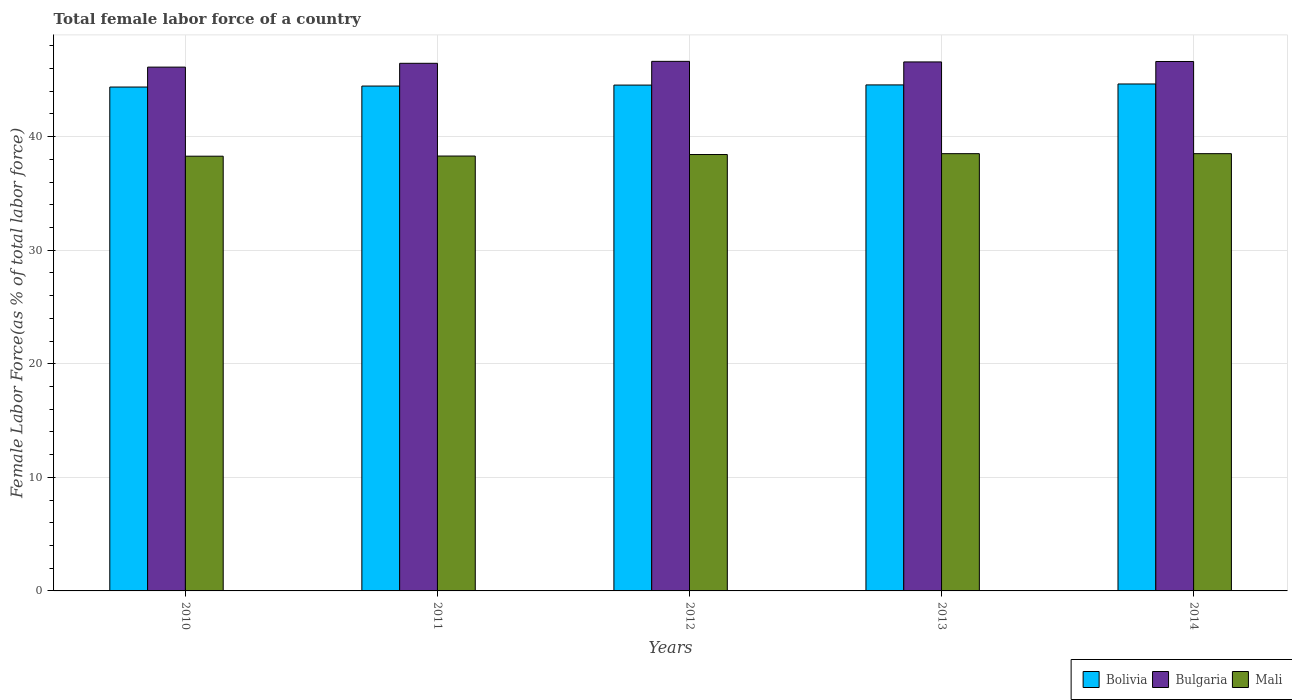How many different coloured bars are there?
Keep it short and to the point. 3. How many groups of bars are there?
Your response must be concise. 5. In how many cases, is the number of bars for a given year not equal to the number of legend labels?
Make the answer very short. 0. What is the percentage of female labor force in Bolivia in 2012?
Provide a short and direct response. 44.53. Across all years, what is the maximum percentage of female labor force in Bulgaria?
Make the answer very short. 46.62. Across all years, what is the minimum percentage of female labor force in Bolivia?
Offer a terse response. 44.36. What is the total percentage of female labor force in Bulgaria in the graph?
Provide a short and direct response. 232.37. What is the difference between the percentage of female labor force in Mali in 2010 and that in 2013?
Your answer should be compact. -0.22. What is the difference between the percentage of female labor force in Mali in 2014 and the percentage of female labor force in Bulgaria in 2013?
Give a very brief answer. -8.08. What is the average percentage of female labor force in Bulgaria per year?
Provide a succinct answer. 46.47. In the year 2012, what is the difference between the percentage of female labor force in Mali and percentage of female labor force in Bulgaria?
Provide a short and direct response. -8.2. In how many years, is the percentage of female labor force in Bolivia greater than 22 %?
Ensure brevity in your answer.  5. What is the ratio of the percentage of female labor force in Bolivia in 2010 to that in 2012?
Offer a terse response. 1. Is the percentage of female labor force in Bolivia in 2011 less than that in 2014?
Provide a succinct answer. Yes. What is the difference between the highest and the second highest percentage of female labor force in Mali?
Keep it short and to the point. 0. What is the difference between the highest and the lowest percentage of female labor force in Mali?
Ensure brevity in your answer.  0.22. What does the 3rd bar from the left in 2013 represents?
Your answer should be compact. Mali. What does the 1st bar from the right in 2011 represents?
Ensure brevity in your answer.  Mali. How many bars are there?
Provide a short and direct response. 15. How many years are there in the graph?
Your answer should be compact. 5. Are the values on the major ticks of Y-axis written in scientific E-notation?
Give a very brief answer. No. How many legend labels are there?
Keep it short and to the point. 3. How are the legend labels stacked?
Your response must be concise. Horizontal. What is the title of the graph?
Make the answer very short. Total female labor force of a country. Does "American Samoa" appear as one of the legend labels in the graph?
Keep it short and to the point. No. What is the label or title of the Y-axis?
Give a very brief answer. Female Labor Force(as % of total labor force). What is the Female Labor Force(as % of total labor force) in Bolivia in 2010?
Your answer should be compact. 44.36. What is the Female Labor Force(as % of total labor force) of Bulgaria in 2010?
Ensure brevity in your answer.  46.11. What is the Female Labor Force(as % of total labor force) of Mali in 2010?
Keep it short and to the point. 38.27. What is the Female Labor Force(as % of total labor force) of Bolivia in 2011?
Your response must be concise. 44.45. What is the Female Labor Force(as % of total labor force) of Bulgaria in 2011?
Ensure brevity in your answer.  46.45. What is the Female Labor Force(as % of total labor force) of Mali in 2011?
Ensure brevity in your answer.  38.29. What is the Female Labor Force(as % of total labor force) of Bolivia in 2012?
Provide a short and direct response. 44.53. What is the Female Labor Force(as % of total labor force) of Bulgaria in 2012?
Give a very brief answer. 46.62. What is the Female Labor Force(as % of total labor force) in Mali in 2012?
Your answer should be very brief. 38.42. What is the Female Labor Force(as % of total labor force) of Bolivia in 2013?
Your answer should be very brief. 44.55. What is the Female Labor Force(as % of total labor force) in Bulgaria in 2013?
Provide a succinct answer. 46.57. What is the Female Labor Force(as % of total labor force) of Mali in 2013?
Give a very brief answer. 38.5. What is the Female Labor Force(as % of total labor force) in Bolivia in 2014?
Ensure brevity in your answer.  44.63. What is the Female Labor Force(as % of total labor force) in Bulgaria in 2014?
Ensure brevity in your answer.  46.61. What is the Female Labor Force(as % of total labor force) of Mali in 2014?
Your answer should be compact. 38.5. Across all years, what is the maximum Female Labor Force(as % of total labor force) in Bolivia?
Provide a short and direct response. 44.63. Across all years, what is the maximum Female Labor Force(as % of total labor force) of Bulgaria?
Your response must be concise. 46.62. Across all years, what is the maximum Female Labor Force(as % of total labor force) of Mali?
Provide a succinct answer. 38.5. Across all years, what is the minimum Female Labor Force(as % of total labor force) of Bolivia?
Your answer should be compact. 44.36. Across all years, what is the minimum Female Labor Force(as % of total labor force) in Bulgaria?
Offer a very short reply. 46.11. Across all years, what is the minimum Female Labor Force(as % of total labor force) in Mali?
Provide a short and direct response. 38.27. What is the total Female Labor Force(as % of total labor force) of Bolivia in the graph?
Your answer should be very brief. 222.52. What is the total Female Labor Force(as % of total labor force) of Bulgaria in the graph?
Keep it short and to the point. 232.37. What is the total Female Labor Force(as % of total labor force) of Mali in the graph?
Offer a terse response. 191.97. What is the difference between the Female Labor Force(as % of total labor force) in Bolivia in 2010 and that in 2011?
Offer a terse response. -0.09. What is the difference between the Female Labor Force(as % of total labor force) in Bulgaria in 2010 and that in 2011?
Your answer should be very brief. -0.34. What is the difference between the Female Labor Force(as % of total labor force) in Mali in 2010 and that in 2011?
Provide a succinct answer. -0.01. What is the difference between the Female Labor Force(as % of total labor force) of Bolivia in 2010 and that in 2012?
Provide a short and direct response. -0.17. What is the difference between the Female Labor Force(as % of total labor force) in Bulgaria in 2010 and that in 2012?
Provide a succinct answer. -0.51. What is the difference between the Female Labor Force(as % of total labor force) in Mali in 2010 and that in 2012?
Provide a succinct answer. -0.15. What is the difference between the Female Labor Force(as % of total labor force) of Bolivia in 2010 and that in 2013?
Provide a succinct answer. -0.19. What is the difference between the Female Labor Force(as % of total labor force) in Bulgaria in 2010 and that in 2013?
Your answer should be very brief. -0.46. What is the difference between the Female Labor Force(as % of total labor force) in Mali in 2010 and that in 2013?
Offer a terse response. -0.22. What is the difference between the Female Labor Force(as % of total labor force) in Bolivia in 2010 and that in 2014?
Your answer should be very brief. -0.27. What is the difference between the Female Labor Force(as % of total labor force) in Bulgaria in 2010 and that in 2014?
Give a very brief answer. -0.5. What is the difference between the Female Labor Force(as % of total labor force) in Mali in 2010 and that in 2014?
Your answer should be very brief. -0.22. What is the difference between the Female Labor Force(as % of total labor force) of Bolivia in 2011 and that in 2012?
Keep it short and to the point. -0.09. What is the difference between the Female Labor Force(as % of total labor force) of Bulgaria in 2011 and that in 2012?
Keep it short and to the point. -0.17. What is the difference between the Female Labor Force(as % of total labor force) of Mali in 2011 and that in 2012?
Make the answer very short. -0.13. What is the difference between the Female Labor Force(as % of total labor force) in Bulgaria in 2011 and that in 2013?
Provide a succinct answer. -0.12. What is the difference between the Female Labor Force(as % of total labor force) of Mali in 2011 and that in 2013?
Offer a terse response. -0.21. What is the difference between the Female Labor Force(as % of total labor force) in Bolivia in 2011 and that in 2014?
Provide a short and direct response. -0.18. What is the difference between the Female Labor Force(as % of total labor force) in Bulgaria in 2011 and that in 2014?
Your answer should be compact. -0.16. What is the difference between the Female Labor Force(as % of total labor force) in Mali in 2011 and that in 2014?
Offer a terse response. -0.21. What is the difference between the Female Labor Force(as % of total labor force) in Bolivia in 2012 and that in 2013?
Your answer should be very brief. -0.01. What is the difference between the Female Labor Force(as % of total labor force) of Bulgaria in 2012 and that in 2013?
Provide a succinct answer. 0.05. What is the difference between the Female Labor Force(as % of total labor force) in Mali in 2012 and that in 2013?
Your answer should be very brief. -0.08. What is the difference between the Female Labor Force(as % of total labor force) of Bolivia in 2012 and that in 2014?
Give a very brief answer. -0.1. What is the difference between the Female Labor Force(as % of total labor force) of Bulgaria in 2012 and that in 2014?
Keep it short and to the point. 0.01. What is the difference between the Female Labor Force(as % of total labor force) in Mali in 2012 and that in 2014?
Your answer should be very brief. -0.08. What is the difference between the Female Labor Force(as % of total labor force) of Bolivia in 2013 and that in 2014?
Provide a short and direct response. -0.08. What is the difference between the Female Labor Force(as % of total labor force) in Bulgaria in 2013 and that in 2014?
Provide a short and direct response. -0.04. What is the difference between the Female Labor Force(as % of total labor force) of Mali in 2013 and that in 2014?
Provide a short and direct response. -0. What is the difference between the Female Labor Force(as % of total labor force) of Bolivia in 2010 and the Female Labor Force(as % of total labor force) of Bulgaria in 2011?
Give a very brief answer. -2.09. What is the difference between the Female Labor Force(as % of total labor force) of Bolivia in 2010 and the Female Labor Force(as % of total labor force) of Mali in 2011?
Give a very brief answer. 6.08. What is the difference between the Female Labor Force(as % of total labor force) of Bulgaria in 2010 and the Female Labor Force(as % of total labor force) of Mali in 2011?
Offer a terse response. 7.83. What is the difference between the Female Labor Force(as % of total labor force) in Bolivia in 2010 and the Female Labor Force(as % of total labor force) in Bulgaria in 2012?
Offer a terse response. -2.26. What is the difference between the Female Labor Force(as % of total labor force) of Bolivia in 2010 and the Female Labor Force(as % of total labor force) of Mali in 2012?
Provide a short and direct response. 5.94. What is the difference between the Female Labor Force(as % of total labor force) in Bulgaria in 2010 and the Female Labor Force(as % of total labor force) in Mali in 2012?
Provide a short and direct response. 7.7. What is the difference between the Female Labor Force(as % of total labor force) of Bolivia in 2010 and the Female Labor Force(as % of total labor force) of Bulgaria in 2013?
Your response must be concise. -2.21. What is the difference between the Female Labor Force(as % of total labor force) in Bolivia in 2010 and the Female Labor Force(as % of total labor force) in Mali in 2013?
Provide a succinct answer. 5.87. What is the difference between the Female Labor Force(as % of total labor force) of Bulgaria in 2010 and the Female Labor Force(as % of total labor force) of Mali in 2013?
Provide a succinct answer. 7.62. What is the difference between the Female Labor Force(as % of total labor force) in Bolivia in 2010 and the Female Labor Force(as % of total labor force) in Bulgaria in 2014?
Keep it short and to the point. -2.25. What is the difference between the Female Labor Force(as % of total labor force) of Bolivia in 2010 and the Female Labor Force(as % of total labor force) of Mali in 2014?
Your response must be concise. 5.87. What is the difference between the Female Labor Force(as % of total labor force) in Bulgaria in 2010 and the Female Labor Force(as % of total labor force) in Mali in 2014?
Your answer should be compact. 7.62. What is the difference between the Female Labor Force(as % of total labor force) of Bolivia in 2011 and the Female Labor Force(as % of total labor force) of Bulgaria in 2012?
Ensure brevity in your answer.  -2.17. What is the difference between the Female Labor Force(as % of total labor force) in Bolivia in 2011 and the Female Labor Force(as % of total labor force) in Mali in 2012?
Keep it short and to the point. 6.03. What is the difference between the Female Labor Force(as % of total labor force) in Bulgaria in 2011 and the Female Labor Force(as % of total labor force) in Mali in 2012?
Offer a terse response. 8.03. What is the difference between the Female Labor Force(as % of total labor force) of Bolivia in 2011 and the Female Labor Force(as % of total labor force) of Bulgaria in 2013?
Provide a short and direct response. -2.12. What is the difference between the Female Labor Force(as % of total labor force) in Bolivia in 2011 and the Female Labor Force(as % of total labor force) in Mali in 2013?
Your response must be concise. 5.95. What is the difference between the Female Labor Force(as % of total labor force) in Bulgaria in 2011 and the Female Labor Force(as % of total labor force) in Mali in 2013?
Keep it short and to the point. 7.96. What is the difference between the Female Labor Force(as % of total labor force) of Bolivia in 2011 and the Female Labor Force(as % of total labor force) of Bulgaria in 2014?
Ensure brevity in your answer.  -2.16. What is the difference between the Female Labor Force(as % of total labor force) of Bolivia in 2011 and the Female Labor Force(as % of total labor force) of Mali in 2014?
Your response must be concise. 5.95. What is the difference between the Female Labor Force(as % of total labor force) of Bulgaria in 2011 and the Female Labor Force(as % of total labor force) of Mali in 2014?
Provide a succinct answer. 7.95. What is the difference between the Female Labor Force(as % of total labor force) of Bolivia in 2012 and the Female Labor Force(as % of total labor force) of Bulgaria in 2013?
Your answer should be compact. -2.04. What is the difference between the Female Labor Force(as % of total labor force) in Bolivia in 2012 and the Female Labor Force(as % of total labor force) in Mali in 2013?
Your response must be concise. 6.04. What is the difference between the Female Labor Force(as % of total labor force) of Bulgaria in 2012 and the Female Labor Force(as % of total labor force) of Mali in 2013?
Make the answer very short. 8.13. What is the difference between the Female Labor Force(as % of total labor force) of Bolivia in 2012 and the Female Labor Force(as % of total labor force) of Bulgaria in 2014?
Ensure brevity in your answer.  -2.08. What is the difference between the Female Labor Force(as % of total labor force) of Bolivia in 2012 and the Female Labor Force(as % of total labor force) of Mali in 2014?
Offer a terse response. 6.04. What is the difference between the Female Labor Force(as % of total labor force) in Bulgaria in 2012 and the Female Labor Force(as % of total labor force) in Mali in 2014?
Your response must be concise. 8.13. What is the difference between the Female Labor Force(as % of total labor force) of Bolivia in 2013 and the Female Labor Force(as % of total labor force) of Bulgaria in 2014?
Give a very brief answer. -2.06. What is the difference between the Female Labor Force(as % of total labor force) in Bolivia in 2013 and the Female Labor Force(as % of total labor force) in Mali in 2014?
Keep it short and to the point. 6.05. What is the difference between the Female Labor Force(as % of total labor force) in Bulgaria in 2013 and the Female Labor Force(as % of total labor force) in Mali in 2014?
Make the answer very short. 8.08. What is the average Female Labor Force(as % of total labor force) of Bolivia per year?
Provide a short and direct response. 44.5. What is the average Female Labor Force(as % of total labor force) in Bulgaria per year?
Your answer should be compact. 46.47. What is the average Female Labor Force(as % of total labor force) in Mali per year?
Provide a short and direct response. 38.39. In the year 2010, what is the difference between the Female Labor Force(as % of total labor force) of Bolivia and Female Labor Force(as % of total labor force) of Bulgaria?
Provide a succinct answer. -1.75. In the year 2010, what is the difference between the Female Labor Force(as % of total labor force) in Bolivia and Female Labor Force(as % of total labor force) in Mali?
Give a very brief answer. 6.09. In the year 2010, what is the difference between the Female Labor Force(as % of total labor force) of Bulgaria and Female Labor Force(as % of total labor force) of Mali?
Your response must be concise. 7.84. In the year 2011, what is the difference between the Female Labor Force(as % of total labor force) of Bolivia and Female Labor Force(as % of total labor force) of Bulgaria?
Keep it short and to the point. -2. In the year 2011, what is the difference between the Female Labor Force(as % of total labor force) of Bolivia and Female Labor Force(as % of total labor force) of Mali?
Provide a short and direct response. 6.16. In the year 2011, what is the difference between the Female Labor Force(as % of total labor force) of Bulgaria and Female Labor Force(as % of total labor force) of Mali?
Ensure brevity in your answer.  8.16. In the year 2012, what is the difference between the Female Labor Force(as % of total labor force) of Bolivia and Female Labor Force(as % of total labor force) of Bulgaria?
Make the answer very short. -2.09. In the year 2012, what is the difference between the Female Labor Force(as % of total labor force) of Bolivia and Female Labor Force(as % of total labor force) of Mali?
Offer a terse response. 6.11. In the year 2012, what is the difference between the Female Labor Force(as % of total labor force) of Bulgaria and Female Labor Force(as % of total labor force) of Mali?
Keep it short and to the point. 8.2. In the year 2013, what is the difference between the Female Labor Force(as % of total labor force) in Bolivia and Female Labor Force(as % of total labor force) in Bulgaria?
Keep it short and to the point. -2.02. In the year 2013, what is the difference between the Female Labor Force(as % of total labor force) of Bolivia and Female Labor Force(as % of total labor force) of Mali?
Your answer should be compact. 6.05. In the year 2013, what is the difference between the Female Labor Force(as % of total labor force) of Bulgaria and Female Labor Force(as % of total labor force) of Mali?
Ensure brevity in your answer.  8.08. In the year 2014, what is the difference between the Female Labor Force(as % of total labor force) in Bolivia and Female Labor Force(as % of total labor force) in Bulgaria?
Ensure brevity in your answer.  -1.98. In the year 2014, what is the difference between the Female Labor Force(as % of total labor force) in Bolivia and Female Labor Force(as % of total labor force) in Mali?
Keep it short and to the point. 6.14. In the year 2014, what is the difference between the Female Labor Force(as % of total labor force) in Bulgaria and Female Labor Force(as % of total labor force) in Mali?
Give a very brief answer. 8.11. What is the ratio of the Female Labor Force(as % of total labor force) in Bulgaria in 2010 to that in 2011?
Your answer should be compact. 0.99. What is the ratio of the Female Labor Force(as % of total labor force) in Bolivia in 2010 to that in 2013?
Offer a very short reply. 1. What is the ratio of the Female Labor Force(as % of total labor force) of Bulgaria in 2010 to that in 2013?
Give a very brief answer. 0.99. What is the ratio of the Female Labor Force(as % of total labor force) in Bulgaria in 2010 to that in 2014?
Offer a terse response. 0.99. What is the ratio of the Female Labor Force(as % of total labor force) of Bolivia in 2011 to that in 2012?
Your answer should be compact. 1. What is the ratio of the Female Labor Force(as % of total labor force) in Mali in 2011 to that in 2012?
Offer a very short reply. 1. What is the ratio of the Female Labor Force(as % of total labor force) of Bolivia in 2011 to that in 2013?
Offer a very short reply. 1. What is the ratio of the Female Labor Force(as % of total labor force) in Bulgaria in 2011 to that in 2013?
Give a very brief answer. 1. What is the ratio of the Female Labor Force(as % of total labor force) in Mali in 2011 to that in 2013?
Make the answer very short. 0.99. What is the ratio of the Female Labor Force(as % of total labor force) in Bolivia in 2011 to that in 2014?
Your answer should be compact. 1. What is the ratio of the Female Labor Force(as % of total labor force) of Bulgaria in 2012 to that in 2014?
Provide a short and direct response. 1. What is the difference between the highest and the second highest Female Labor Force(as % of total labor force) of Bolivia?
Provide a succinct answer. 0.08. What is the difference between the highest and the second highest Female Labor Force(as % of total labor force) in Bulgaria?
Keep it short and to the point. 0.01. What is the difference between the highest and the second highest Female Labor Force(as % of total labor force) in Mali?
Make the answer very short. 0. What is the difference between the highest and the lowest Female Labor Force(as % of total labor force) of Bolivia?
Your answer should be compact. 0.27. What is the difference between the highest and the lowest Female Labor Force(as % of total labor force) of Bulgaria?
Provide a succinct answer. 0.51. What is the difference between the highest and the lowest Female Labor Force(as % of total labor force) in Mali?
Make the answer very short. 0.22. 